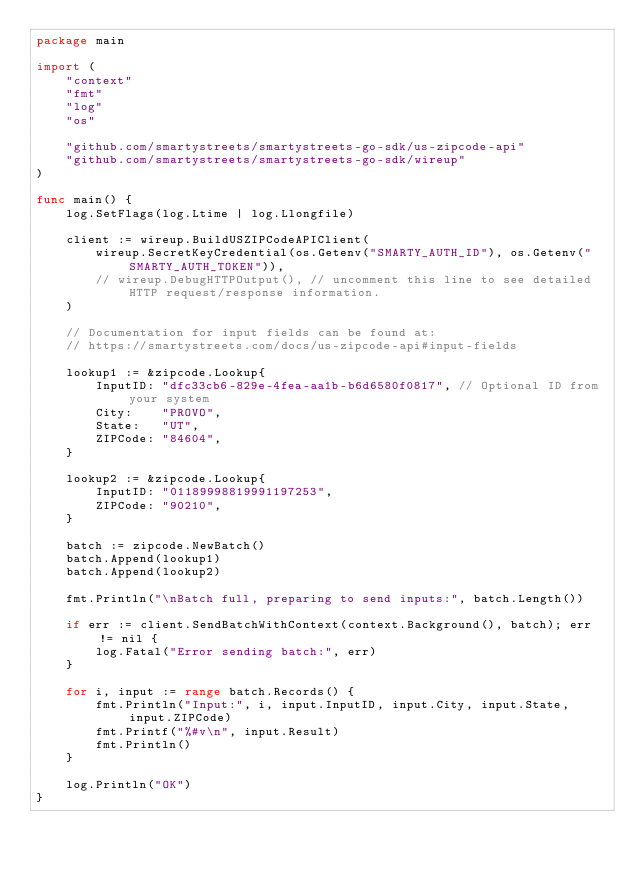Convert code to text. <code><loc_0><loc_0><loc_500><loc_500><_Go_>package main

import (
	"context"
	"fmt"
	"log"
	"os"

	"github.com/smartystreets/smartystreets-go-sdk/us-zipcode-api"
	"github.com/smartystreets/smartystreets-go-sdk/wireup"
)

func main() {
	log.SetFlags(log.Ltime | log.Llongfile)

	client := wireup.BuildUSZIPCodeAPIClient(
		wireup.SecretKeyCredential(os.Getenv("SMARTY_AUTH_ID"), os.Getenv("SMARTY_AUTH_TOKEN")),
		// wireup.DebugHTTPOutput(), // uncomment this line to see detailed HTTP request/response information.
	)

	// Documentation for input fields can be found at:
	// https://smartystreets.com/docs/us-zipcode-api#input-fields

	lookup1 := &zipcode.Lookup{
		InputID: "dfc33cb6-829e-4fea-aa1b-b6d6580f0817", // Optional ID from your system
		City:    "PROVO",
		State:   "UT",
		ZIPCode: "84604",
	}

	lookup2 := &zipcode.Lookup{
		InputID: "01189998819991197253",
		ZIPCode: "90210",
	}

	batch := zipcode.NewBatch()
	batch.Append(lookup1)
	batch.Append(lookup2)

	fmt.Println("\nBatch full, preparing to send inputs:", batch.Length())

	if err := client.SendBatchWithContext(context.Background(), batch); err != nil {
		log.Fatal("Error sending batch:", err)
	}

	for i, input := range batch.Records() {
		fmt.Println("Input:", i, input.InputID, input.City, input.State, input.ZIPCode)
		fmt.Printf("%#v\n", input.Result)
		fmt.Println()
	}

	log.Println("OK")
}
</code> 